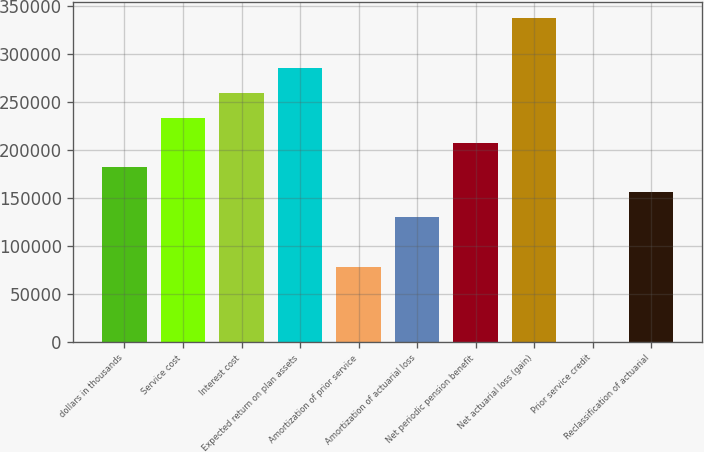<chart> <loc_0><loc_0><loc_500><loc_500><bar_chart><fcel>dollars in thousands<fcel>Service cost<fcel>Interest cost<fcel>Expected return on plan assets<fcel>Amortization of prior service<fcel>Amortization of actuarial loss<fcel>Net periodic pension benefit<fcel>Net actuarial loss (gain)<fcel>Prior service credit<fcel>Reclassification of actuarial<nl><fcel>181517<fcel>233378<fcel>259308<fcel>285238<fcel>77795.4<fcel>129656<fcel>207447<fcel>337099<fcel>4.29<fcel>155587<nl></chart> 